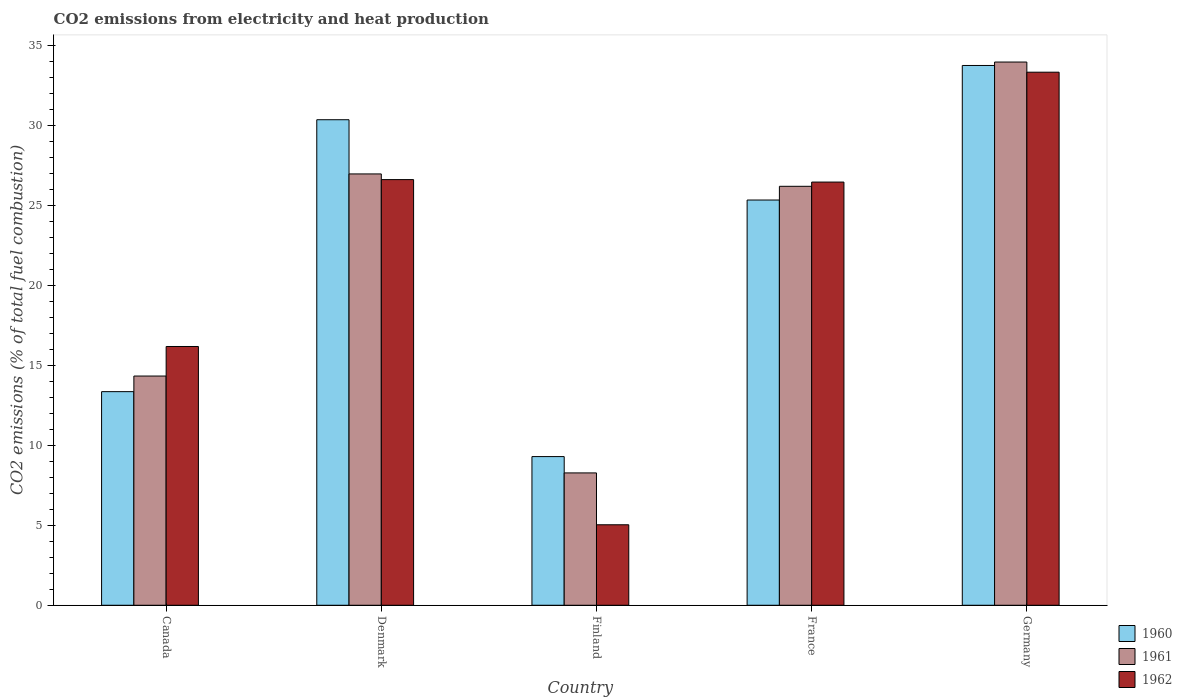How many groups of bars are there?
Make the answer very short. 5. How many bars are there on the 1st tick from the left?
Keep it short and to the point. 3. What is the amount of CO2 emitted in 1960 in Canada?
Keep it short and to the point. 13.35. Across all countries, what is the maximum amount of CO2 emitted in 1962?
Keep it short and to the point. 33.31. Across all countries, what is the minimum amount of CO2 emitted in 1962?
Give a very brief answer. 5.03. In which country was the amount of CO2 emitted in 1960 maximum?
Offer a very short reply. Germany. What is the total amount of CO2 emitted in 1960 in the graph?
Your response must be concise. 112.01. What is the difference between the amount of CO2 emitted in 1961 in France and that in Germany?
Give a very brief answer. -7.76. What is the difference between the amount of CO2 emitted in 1962 in Canada and the amount of CO2 emitted in 1960 in Finland?
Provide a short and direct response. 6.88. What is the average amount of CO2 emitted in 1960 per country?
Keep it short and to the point. 22.4. What is the difference between the amount of CO2 emitted of/in 1961 and amount of CO2 emitted of/in 1960 in Finland?
Your answer should be compact. -1.02. In how many countries, is the amount of CO2 emitted in 1960 greater than 5 %?
Offer a terse response. 5. What is the ratio of the amount of CO2 emitted in 1960 in Canada to that in Denmark?
Provide a short and direct response. 0.44. Is the difference between the amount of CO2 emitted in 1961 in Canada and France greater than the difference between the amount of CO2 emitted in 1960 in Canada and France?
Give a very brief answer. Yes. What is the difference between the highest and the second highest amount of CO2 emitted in 1961?
Ensure brevity in your answer.  6.99. What is the difference between the highest and the lowest amount of CO2 emitted in 1960?
Your response must be concise. 24.44. In how many countries, is the amount of CO2 emitted in 1962 greater than the average amount of CO2 emitted in 1962 taken over all countries?
Ensure brevity in your answer.  3. What does the 2nd bar from the left in Finland represents?
Provide a succinct answer. 1961. Is it the case that in every country, the sum of the amount of CO2 emitted in 1960 and amount of CO2 emitted in 1962 is greater than the amount of CO2 emitted in 1961?
Give a very brief answer. Yes. How many bars are there?
Ensure brevity in your answer.  15. Are the values on the major ticks of Y-axis written in scientific E-notation?
Provide a short and direct response. No. Does the graph contain any zero values?
Provide a short and direct response. No. Does the graph contain grids?
Provide a short and direct response. No. What is the title of the graph?
Offer a terse response. CO2 emissions from electricity and heat production. What is the label or title of the Y-axis?
Give a very brief answer. CO2 emissions (% of total fuel combustion). What is the CO2 emissions (% of total fuel combustion) in 1960 in Canada?
Provide a succinct answer. 13.35. What is the CO2 emissions (% of total fuel combustion) in 1961 in Canada?
Your response must be concise. 14.32. What is the CO2 emissions (% of total fuel combustion) of 1962 in Canada?
Your answer should be very brief. 16.17. What is the CO2 emissions (% of total fuel combustion) in 1960 in Denmark?
Offer a terse response. 30.34. What is the CO2 emissions (% of total fuel combustion) of 1961 in Denmark?
Make the answer very short. 26.95. What is the CO2 emissions (% of total fuel combustion) of 1962 in Denmark?
Offer a very short reply. 26.59. What is the CO2 emissions (% of total fuel combustion) of 1960 in Finland?
Make the answer very short. 9.29. What is the CO2 emissions (% of total fuel combustion) in 1961 in Finland?
Offer a very short reply. 8.27. What is the CO2 emissions (% of total fuel combustion) of 1962 in Finland?
Provide a short and direct response. 5.03. What is the CO2 emissions (% of total fuel combustion) in 1960 in France?
Provide a short and direct response. 25.32. What is the CO2 emissions (% of total fuel combustion) of 1961 in France?
Ensure brevity in your answer.  26.18. What is the CO2 emissions (% of total fuel combustion) in 1962 in France?
Keep it short and to the point. 26.44. What is the CO2 emissions (% of total fuel combustion) of 1960 in Germany?
Keep it short and to the point. 33.72. What is the CO2 emissions (% of total fuel combustion) in 1961 in Germany?
Your answer should be compact. 33.94. What is the CO2 emissions (% of total fuel combustion) in 1962 in Germany?
Ensure brevity in your answer.  33.31. Across all countries, what is the maximum CO2 emissions (% of total fuel combustion) in 1960?
Provide a short and direct response. 33.72. Across all countries, what is the maximum CO2 emissions (% of total fuel combustion) in 1961?
Give a very brief answer. 33.94. Across all countries, what is the maximum CO2 emissions (% of total fuel combustion) in 1962?
Your response must be concise. 33.31. Across all countries, what is the minimum CO2 emissions (% of total fuel combustion) in 1960?
Give a very brief answer. 9.29. Across all countries, what is the minimum CO2 emissions (% of total fuel combustion) in 1961?
Your response must be concise. 8.27. Across all countries, what is the minimum CO2 emissions (% of total fuel combustion) in 1962?
Your answer should be very brief. 5.03. What is the total CO2 emissions (% of total fuel combustion) of 1960 in the graph?
Offer a very short reply. 112.01. What is the total CO2 emissions (% of total fuel combustion) in 1961 in the graph?
Ensure brevity in your answer.  109.65. What is the total CO2 emissions (% of total fuel combustion) in 1962 in the graph?
Provide a succinct answer. 107.53. What is the difference between the CO2 emissions (% of total fuel combustion) of 1960 in Canada and that in Denmark?
Keep it short and to the point. -16.99. What is the difference between the CO2 emissions (% of total fuel combustion) in 1961 in Canada and that in Denmark?
Ensure brevity in your answer.  -12.63. What is the difference between the CO2 emissions (% of total fuel combustion) of 1962 in Canada and that in Denmark?
Your answer should be very brief. -10.43. What is the difference between the CO2 emissions (% of total fuel combustion) of 1960 in Canada and that in Finland?
Provide a succinct answer. 4.06. What is the difference between the CO2 emissions (% of total fuel combustion) of 1961 in Canada and that in Finland?
Give a very brief answer. 6.05. What is the difference between the CO2 emissions (% of total fuel combustion) of 1962 in Canada and that in Finland?
Ensure brevity in your answer.  11.14. What is the difference between the CO2 emissions (% of total fuel combustion) of 1960 in Canada and that in France?
Give a very brief answer. -11.97. What is the difference between the CO2 emissions (% of total fuel combustion) in 1961 in Canada and that in France?
Ensure brevity in your answer.  -11.85. What is the difference between the CO2 emissions (% of total fuel combustion) of 1962 in Canada and that in France?
Provide a short and direct response. -10.27. What is the difference between the CO2 emissions (% of total fuel combustion) in 1960 in Canada and that in Germany?
Provide a short and direct response. -20.38. What is the difference between the CO2 emissions (% of total fuel combustion) of 1961 in Canada and that in Germany?
Provide a succinct answer. -19.62. What is the difference between the CO2 emissions (% of total fuel combustion) in 1962 in Canada and that in Germany?
Your answer should be very brief. -17.14. What is the difference between the CO2 emissions (% of total fuel combustion) of 1960 in Denmark and that in Finland?
Provide a succinct answer. 21.05. What is the difference between the CO2 emissions (% of total fuel combustion) of 1961 in Denmark and that in Finland?
Keep it short and to the point. 18.68. What is the difference between the CO2 emissions (% of total fuel combustion) of 1962 in Denmark and that in Finland?
Your response must be concise. 21.57. What is the difference between the CO2 emissions (% of total fuel combustion) of 1960 in Denmark and that in France?
Provide a succinct answer. 5.02. What is the difference between the CO2 emissions (% of total fuel combustion) in 1961 in Denmark and that in France?
Provide a succinct answer. 0.77. What is the difference between the CO2 emissions (% of total fuel combustion) in 1962 in Denmark and that in France?
Give a very brief answer. 0.15. What is the difference between the CO2 emissions (% of total fuel combustion) in 1960 in Denmark and that in Germany?
Your answer should be very brief. -3.39. What is the difference between the CO2 emissions (% of total fuel combustion) of 1961 in Denmark and that in Germany?
Your answer should be very brief. -6.99. What is the difference between the CO2 emissions (% of total fuel combustion) in 1962 in Denmark and that in Germany?
Your response must be concise. -6.71. What is the difference between the CO2 emissions (% of total fuel combustion) in 1960 in Finland and that in France?
Provide a succinct answer. -16.03. What is the difference between the CO2 emissions (% of total fuel combustion) in 1961 in Finland and that in France?
Provide a succinct answer. -17.91. What is the difference between the CO2 emissions (% of total fuel combustion) of 1962 in Finland and that in France?
Provide a succinct answer. -21.41. What is the difference between the CO2 emissions (% of total fuel combustion) in 1960 in Finland and that in Germany?
Keep it short and to the point. -24.44. What is the difference between the CO2 emissions (% of total fuel combustion) of 1961 in Finland and that in Germany?
Offer a very short reply. -25.67. What is the difference between the CO2 emissions (% of total fuel combustion) of 1962 in Finland and that in Germany?
Ensure brevity in your answer.  -28.28. What is the difference between the CO2 emissions (% of total fuel combustion) in 1960 in France and that in Germany?
Offer a terse response. -8.41. What is the difference between the CO2 emissions (% of total fuel combustion) of 1961 in France and that in Germany?
Your answer should be compact. -7.76. What is the difference between the CO2 emissions (% of total fuel combustion) of 1962 in France and that in Germany?
Provide a short and direct response. -6.87. What is the difference between the CO2 emissions (% of total fuel combustion) in 1960 in Canada and the CO2 emissions (% of total fuel combustion) in 1961 in Denmark?
Your answer should be very brief. -13.6. What is the difference between the CO2 emissions (% of total fuel combustion) in 1960 in Canada and the CO2 emissions (% of total fuel combustion) in 1962 in Denmark?
Provide a short and direct response. -13.25. What is the difference between the CO2 emissions (% of total fuel combustion) in 1961 in Canada and the CO2 emissions (% of total fuel combustion) in 1962 in Denmark?
Make the answer very short. -12.27. What is the difference between the CO2 emissions (% of total fuel combustion) of 1960 in Canada and the CO2 emissions (% of total fuel combustion) of 1961 in Finland?
Ensure brevity in your answer.  5.08. What is the difference between the CO2 emissions (% of total fuel combustion) of 1960 in Canada and the CO2 emissions (% of total fuel combustion) of 1962 in Finland?
Your response must be concise. 8.32. What is the difference between the CO2 emissions (% of total fuel combustion) of 1961 in Canada and the CO2 emissions (% of total fuel combustion) of 1962 in Finland?
Provide a succinct answer. 9.29. What is the difference between the CO2 emissions (% of total fuel combustion) of 1960 in Canada and the CO2 emissions (% of total fuel combustion) of 1961 in France?
Offer a very short reply. -12.83. What is the difference between the CO2 emissions (% of total fuel combustion) of 1960 in Canada and the CO2 emissions (% of total fuel combustion) of 1962 in France?
Your answer should be compact. -13.09. What is the difference between the CO2 emissions (% of total fuel combustion) in 1961 in Canada and the CO2 emissions (% of total fuel combustion) in 1962 in France?
Your answer should be very brief. -12.12. What is the difference between the CO2 emissions (% of total fuel combustion) in 1960 in Canada and the CO2 emissions (% of total fuel combustion) in 1961 in Germany?
Your answer should be very brief. -20.59. What is the difference between the CO2 emissions (% of total fuel combustion) in 1960 in Canada and the CO2 emissions (% of total fuel combustion) in 1962 in Germany?
Your response must be concise. -19.96. What is the difference between the CO2 emissions (% of total fuel combustion) in 1961 in Canada and the CO2 emissions (% of total fuel combustion) in 1962 in Germany?
Your response must be concise. -18.98. What is the difference between the CO2 emissions (% of total fuel combustion) in 1960 in Denmark and the CO2 emissions (% of total fuel combustion) in 1961 in Finland?
Make the answer very short. 22.07. What is the difference between the CO2 emissions (% of total fuel combustion) in 1960 in Denmark and the CO2 emissions (% of total fuel combustion) in 1962 in Finland?
Provide a short and direct response. 25.31. What is the difference between the CO2 emissions (% of total fuel combustion) in 1961 in Denmark and the CO2 emissions (% of total fuel combustion) in 1962 in Finland?
Give a very brief answer. 21.92. What is the difference between the CO2 emissions (% of total fuel combustion) in 1960 in Denmark and the CO2 emissions (% of total fuel combustion) in 1961 in France?
Your response must be concise. 4.16. What is the difference between the CO2 emissions (% of total fuel combustion) in 1960 in Denmark and the CO2 emissions (% of total fuel combustion) in 1962 in France?
Your answer should be compact. 3.9. What is the difference between the CO2 emissions (% of total fuel combustion) of 1961 in Denmark and the CO2 emissions (% of total fuel combustion) of 1962 in France?
Provide a succinct answer. 0.51. What is the difference between the CO2 emissions (% of total fuel combustion) in 1960 in Denmark and the CO2 emissions (% of total fuel combustion) in 1961 in Germany?
Your answer should be compact. -3.6. What is the difference between the CO2 emissions (% of total fuel combustion) in 1960 in Denmark and the CO2 emissions (% of total fuel combustion) in 1962 in Germany?
Keep it short and to the point. -2.97. What is the difference between the CO2 emissions (% of total fuel combustion) in 1961 in Denmark and the CO2 emissions (% of total fuel combustion) in 1962 in Germany?
Keep it short and to the point. -6.36. What is the difference between the CO2 emissions (% of total fuel combustion) of 1960 in Finland and the CO2 emissions (% of total fuel combustion) of 1961 in France?
Offer a very short reply. -16.89. What is the difference between the CO2 emissions (% of total fuel combustion) of 1960 in Finland and the CO2 emissions (% of total fuel combustion) of 1962 in France?
Your response must be concise. -17.15. What is the difference between the CO2 emissions (% of total fuel combustion) in 1961 in Finland and the CO2 emissions (% of total fuel combustion) in 1962 in France?
Make the answer very short. -18.17. What is the difference between the CO2 emissions (% of total fuel combustion) of 1960 in Finland and the CO2 emissions (% of total fuel combustion) of 1961 in Germany?
Your response must be concise. -24.65. What is the difference between the CO2 emissions (% of total fuel combustion) of 1960 in Finland and the CO2 emissions (% of total fuel combustion) of 1962 in Germany?
Offer a very short reply. -24.02. What is the difference between the CO2 emissions (% of total fuel combustion) of 1961 in Finland and the CO2 emissions (% of total fuel combustion) of 1962 in Germany?
Your response must be concise. -25.04. What is the difference between the CO2 emissions (% of total fuel combustion) of 1960 in France and the CO2 emissions (% of total fuel combustion) of 1961 in Germany?
Your answer should be very brief. -8.62. What is the difference between the CO2 emissions (% of total fuel combustion) in 1960 in France and the CO2 emissions (% of total fuel combustion) in 1962 in Germany?
Keep it short and to the point. -7.99. What is the difference between the CO2 emissions (% of total fuel combustion) in 1961 in France and the CO2 emissions (% of total fuel combustion) in 1962 in Germany?
Your answer should be very brief. -7.13. What is the average CO2 emissions (% of total fuel combustion) in 1960 per country?
Provide a short and direct response. 22.4. What is the average CO2 emissions (% of total fuel combustion) of 1961 per country?
Ensure brevity in your answer.  21.93. What is the average CO2 emissions (% of total fuel combustion) of 1962 per country?
Ensure brevity in your answer.  21.51. What is the difference between the CO2 emissions (% of total fuel combustion) of 1960 and CO2 emissions (% of total fuel combustion) of 1961 in Canada?
Make the answer very short. -0.98. What is the difference between the CO2 emissions (% of total fuel combustion) of 1960 and CO2 emissions (% of total fuel combustion) of 1962 in Canada?
Offer a terse response. -2.82. What is the difference between the CO2 emissions (% of total fuel combustion) of 1961 and CO2 emissions (% of total fuel combustion) of 1962 in Canada?
Your answer should be very brief. -1.85. What is the difference between the CO2 emissions (% of total fuel combustion) in 1960 and CO2 emissions (% of total fuel combustion) in 1961 in Denmark?
Your answer should be very brief. 3.39. What is the difference between the CO2 emissions (% of total fuel combustion) in 1960 and CO2 emissions (% of total fuel combustion) in 1962 in Denmark?
Your response must be concise. 3.74. What is the difference between the CO2 emissions (% of total fuel combustion) of 1961 and CO2 emissions (% of total fuel combustion) of 1962 in Denmark?
Provide a short and direct response. 0.35. What is the difference between the CO2 emissions (% of total fuel combustion) in 1960 and CO2 emissions (% of total fuel combustion) in 1961 in Finland?
Keep it short and to the point. 1.02. What is the difference between the CO2 emissions (% of total fuel combustion) of 1960 and CO2 emissions (% of total fuel combustion) of 1962 in Finland?
Offer a terse response. 4.26. What is the difference between the CO2 emissions (% of total fuel combustion) of 1961 and CO2 emissions (% of total fuel combustion) of 1962 in Finland?
Make the answer very short. 3.24. What is the difference between the CO2 emissions (% of total fuel combustion) of 1960 and CO2 emissions (% of total fuel combustion) of 1961 in France?
Provide a succinct answer. -0.86. What is the difference between the CO2 emissions (% of total fuel combustion) in 1960 and CO2 emissions (% of total fuel combustion) in 1962 in France?
Give a very brief answer. -1.12. What is the difference between the CO2 emissions (% of total fuel combustion) of 1961 and CO2 emissions (% of total fuel combustion) of 1962 in France?
Make the answer very short. -0.26. What is the difference between the CO2 emissions (% of total fuel combustion) of 1960 and CO2 emissions (% of total fuel combustion) of 1961 in Germany?
Provide a short and direct response. -0.21. What is the difference between the CO2 emissions (% of total fuel combustion) in 1960 and CO2 emissions (% of total fuel combustion) in 1962 in Germany?
Offer a terse response. 0.42. What is the difference between the CO2 emissions (% of total fuel combustion) in 1961 and CO2 emissions (% of total fuel combustion) in 1962 in Germany?
Offer a very short reply. 0.63. What is the ratio of the CO2 emissions (% of total fuel combustion) of 1960 in Canada to that in Denmark?
Provide a short and direct response. 0.44. What is the ratio of the CO2 emissions (% of total fuel combustion) in 1961 in Canada to that in Denmark?
Your response must be concise. 0.53. What is the ratio of the CO2 emissions (% of total fuel combustion) in 1962 in Canada to that in Denmark?
Your response must be concise. 0.61. What is the ratio of the CO2 emissions (% of total fuel combustion) of 1960 in Canada to that in Finland?
Give a very brief answer. 1.44. What is the ratio of the CO2 emissions (% of total fuel combustion) in 1961 in Canada to that in Finland?
Your answer should be very brief. 1.73. What is the ratio of the CO2 emissions (% of total fuel combustion) in 1962 in Canada to that in Finland?
Offer a very short reply. 3.22. What is the ratio of the CO2 emissions (% of total fuel combustion) in 1960 in Canada to that in France?
Provide a short and direct response. 0.53. What is the ratio of the CO2 emissions (% of total fuel combustion) in 1961 in Canada to that in France?
Ensure brevity in your answer.  0.55. What is the ratio of the CO2 emissions (% of total fuel combustion) of 1962 in Canada to that in France?
Your response must be concise. 0.61. What is the ratio of the CO2 emissions (% of total fuel combustion) of 1960 in Canada to that in Germany?
Make the answer very short. 0.4. What is the ratio of the CO2 emissions (% of total fuel combustion) in 1961 in Canada to that in Germany?
Make the answer very short. 0.42. What is the ratio of the CO2 emissions (% of total fuel combustion) of 1962 in Canada to that in Germany?
Keep it short and to the point. 0.49. What is the ratio of the CO2 emissions (% of total fuel combustion) in 1960 in Denmark to that in Finland?
Offer a terse response. 3.27. What is the ratio of the CO2 emissions (% of total fuel combustion) in 1961 in Denmark to that in Finland?
Keep it short and to the point. 3.26. What is the ratio of the CO2 emissions (% of total fuel combustion) in 1962 in Denmark to that in Finland?
Make the answer very short. 5.29. What is the ratio of the CO2 emissions (% of total fuel combustion) of 1960 in Denmark to that in France?
Offer a terse response. 1.2. What is the ratio of the CO2 emissions (% of total fuel combustion) in 1961 in Denmark to that in France?
Keep it short and to the point. 1.03. What is the ratio of the CO2 emissions (% of total fuel combustion) in 1960 in Denmark to that in Germany?
Provide a short and direct response. 0.9. What is the ratio of the CO2 emissions (% of total fuel combustion) in 1961 in Denmark to that in Germany?
Provide a succinct answer. 0.79. What is the ratio of the CO2 emissions (% of total fuel combustion) in 1962 in Denmark to that in Germany?
Your response must be concise. 0.8. What is the ratio of the CO2 emissions (% of total fuel combustion) in 1960 in Finland to that in France?
Provide a short and direct response. 0.37. What is the ratio of the CO2 emissions (% of total fuel combustion) of 1961 in Finland to that in France?
Provide a succinct answer. 0.32. What is the ratio of the CO2 emissions (% of total fuel combustion) in 1962 in Finland to that in France?
Provide a short and direct response. 0.19. What is the ratio of the CO2 emissions (% of total fuel combustion) of 1960 in Finland to that in Germany?
Keep it short and to the point. 0.28. What is the ratio of the CO2 emissions (% of total fuel combustion) of 1961 in Finland to that in Germany?
Offer a very short reply. 0.24. What is the ratio of the CO2 emissions (% of total fuel combustion) in 1962 in Finland to that in Germany?
Offer a very short reply. 0.15. What is the ratio of the CO2 emissions (% of total fuel combustion) of 1960 in France to that in Germany?
Your answer should be compact. 0.75. What is the ratio of the CO2 emissions (% of total fuel combustion) of 1961 in France to that in Germany?
Ensure brevity in your answer.  0.77. What is the ratio of the CO2 emissions (% of total fuel combustion) in 1962 in France to that in Germany?
Your answer should be very brief. 0.79. What is the difference between the highest and the second highest CO2 emissions (% of total fuel combustion) of 1960?
Make the answer very short. 3.39. What is the difference between the highest and the second highest CO2 emissions (% of total fuel combustion) of 1961?
Make the answer very short. 6.99. What is the difference between the highest and the second highest CO2 emissions (% of total fuel combustion) in 1962?
Your answer should be very brief. 6.71. What is the difference between the highest and the lowest CO2 emissions (% of total fuel combustion) of 1960?
Make the answer very short. 24.44. What is the difference between the highest and the lowest CO2 emissions (% of total fuel combustion) of 1961?
Provide a succinct answer. 25.67. What is the difference between the highest and the lowest CO2 emissions (% of total fuel combustion) of 1962?
Keep it short and to the point. 28.28. 